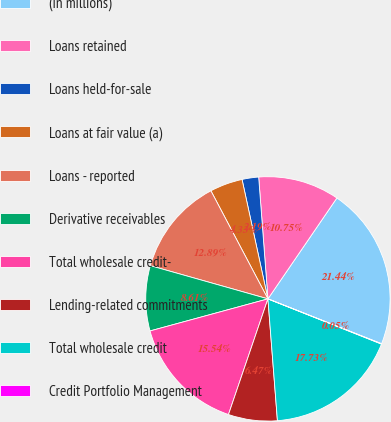Convert chart to OTSL. <chart><loc_0><loc_0><loc_500><loc_500><pie_chart><fcel>(in millions)<fcel>Loans retained<fcel>Loans held-for-sale<fcel>Loans at fair value (a)<fcel>Loans - reported<fcel>Derivative receivables<fcel>Total wholesale credit-<fcel>Lending-related commitments<fcel>Total wholesale credit<fcel>Credit Portfolio Management<nl><fcel>21.44%<fcel>10.75%<fcel>2.19%<fcel>4.33%<fcel>12.89%<fcel>8.61%<fcel>15.54%<fcel>6.47%<fcel>17.73%<fcel>0.05%<nl></chart> 